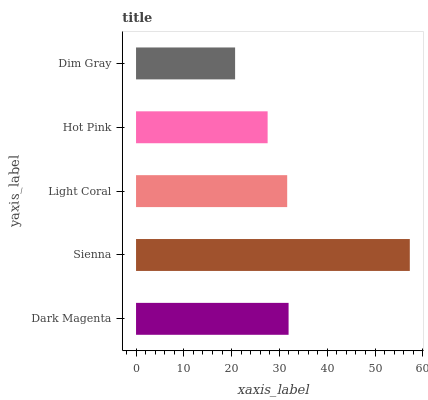Is Dim Gray the minimum?
Answer yes or no. Yes. Is Sienna the maximum?
Answer yes or no. Yes. Is Light Coral the minimum?
Answer yes or no. No. Is Light Coral the maximum?
Answer yes or no. No. Is Sienna greater than Light Coral?
Answer yes or no. Yes. Is Light Coral less than Sienna?
Answer yes or no. Yes. Is Light Coral greater than Sienna?
Answer yes or no. No. Is Sienna less than Light Coral?
Answer yes or no. No. Is Light Coral the high median?
Answer yes or no. Yes. Is Light Coral the low median?
Answer yes or no. Yes. Is Dim Gray the high median?
Answer yes or no. No. Is Dim Gray the low median?
Answer yes or no. No. 